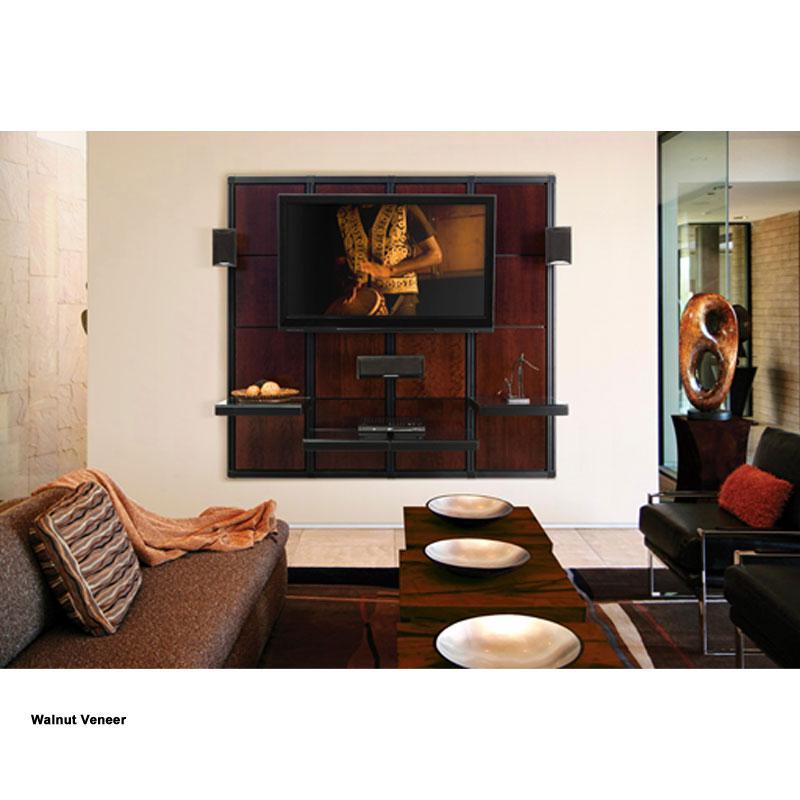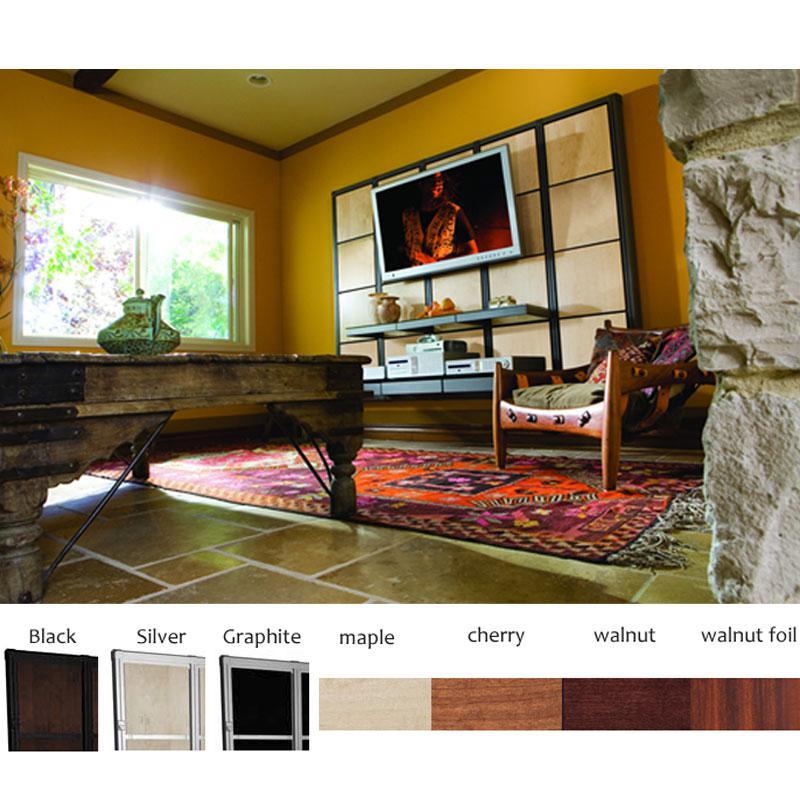The first image is the image on the left, the second image is the image on the right. For the images displayed, is the sentence "Atleast one picture contains a white sofa" factually correct? Answer yes or no. No. The first image is the image on the left, the second image is the image on the right. Evaluate the accuracy of this statement regarding the images: "At least one image has plants.". Is it true? Answer yes or no. No. 